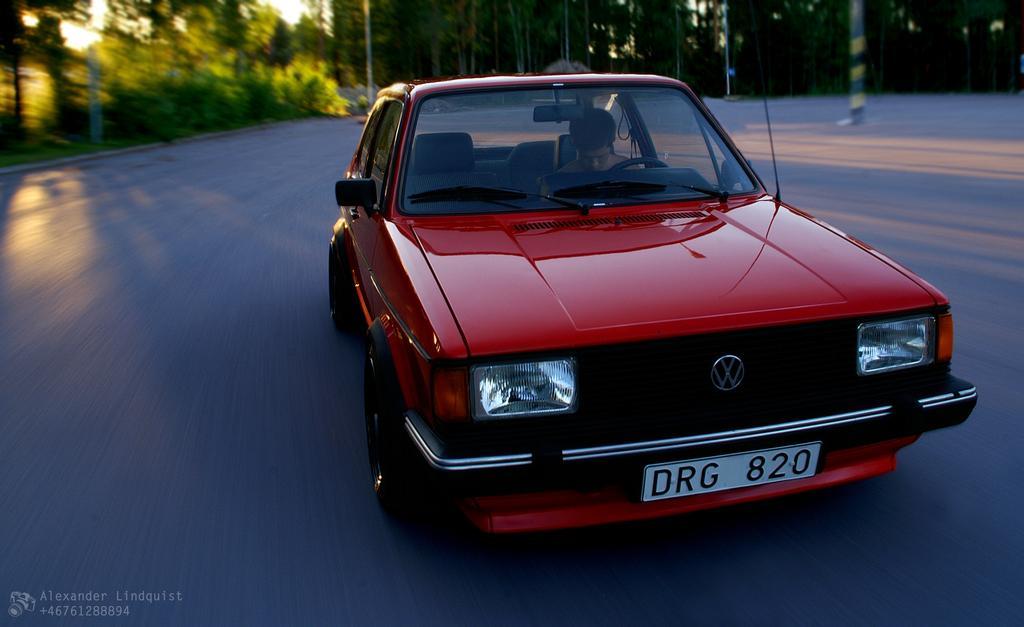In one or two sentences, can you explain what this image depicts? In this image I can see the road and on it I can see a red colour car. I can also see a man in this car and here I can see something is written. In the background I can see number of trees, poles, shadows and over here I can see a watermark. 